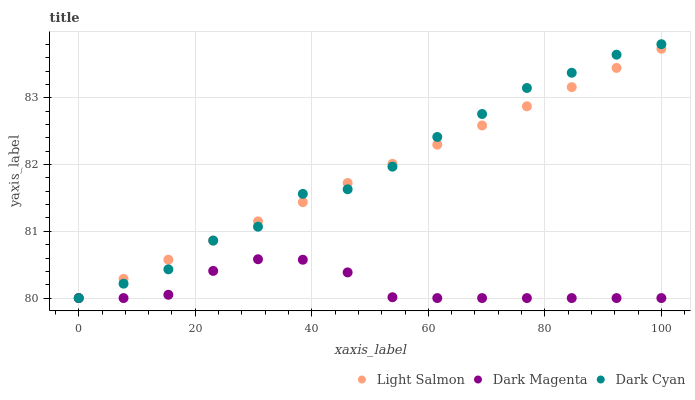Does Dark Magenta have the minimum area under the curve?
Answer yes or no. Yes. Does Dark Cyan have the maximum area under the curve?
Answer yes or no. Yes. Does Light Salmon have the minimum area under the curve?
Answer yes or no. No. Does Light Salmon have the maximum area under the curve?
Answer yes or no. No. Is Light Salmon the smoothest?
Answer yes or no. Yes. Is Dark Cyan the roughest?
Answer yes or no. Yes. Is Dark Magenta the smoothest?
Answer yes or no. No. Is Dark Magenta the roughest?
Answer yes or no. No. Does Dark Cyan have the lowest value?
Answer yes or no. Yes. Does Dark Cyan have the highest value?
Answer yes or no. Yes. Does Light Salmon have the highest value?
Answer yes or no. No. Does Light Salmon intersect Dark Magenta?
Answer yes or no. Yes. Is Light Salmon less than Dark Magenta?
Answer yes or no. No. Is Light Salmon greater than Dark Magenta?
Answer yes or no. No. 